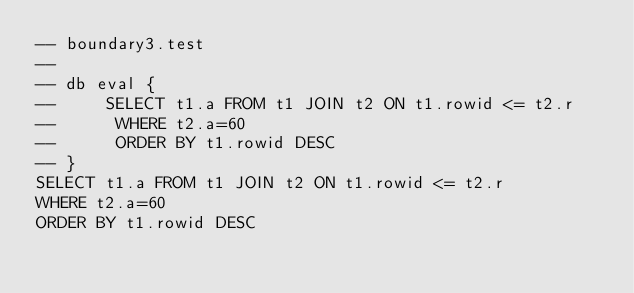<code> <loc_0><loc_0><loc_500><loc_500><_SQL_>-- boundary3.test
-- 
-- db eval {
--     SELECT t1.a FROM t1 JOIN t2 ON t1.rowid <= t2.r
--      WHERE t2.a=60
--      ORDER BY t1.rowid DESC
-- }
SELECT t1.a FROM t1 JOIN t2 ON t1.rowid <= t2.r
WHERE t2.a=60
ORDER BY t1.rowid DESC</code> 